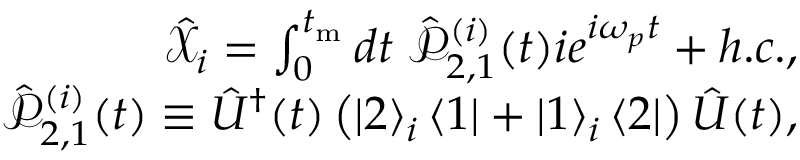Convert formula to latex. <formula><loc_0><loc_0><loc_500><loc_500>\begin{array} { r } { \hat { \mathcal { X } } _ { i } = \int _ { 0 } ^ { t _ { m } } d t \, \hat { \mathcal { P } } _ { 2 , 1 } ^ { ( i ) } ( t ) i e ^ { i \omega _ { p } t } + h . c . , } \\ { \hat { \mathcal { P } } _ { 2 , 1 } ^ { ( i ) } ( t ) \equiv \hat { U } ^ { \dagger } ( t ) \left ( \left | 2 \right > _ { i } \left < 1 \right | + \left | 1 \right > _ { i } \left < 2 \right | \right ) \hat { U } ( t ) , } \end{array}</formula> 